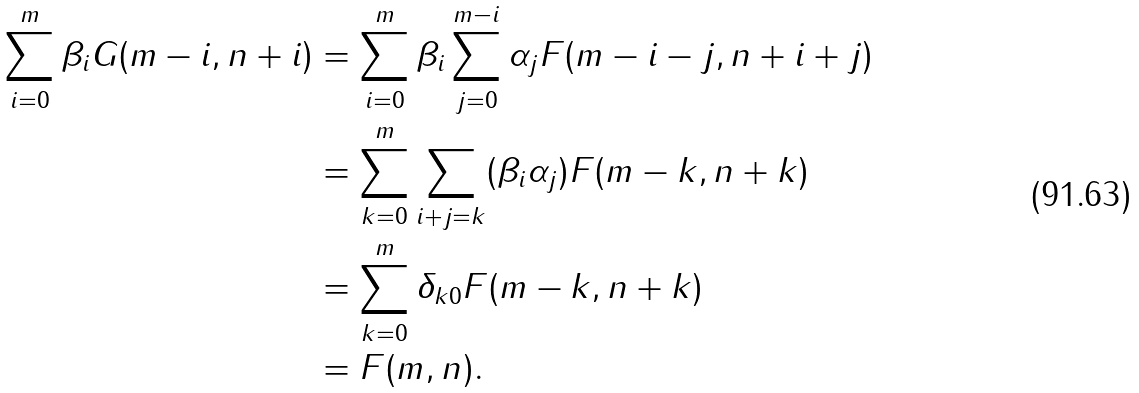<formula> <loc_0><loc_0><loc_500><loc_500>\sum _ { i = 0 } ^ { m } \beta _ { i } G ( m - i , n + i ) & = \sum _ { i = 0 } ^ { m } \beta _ { i } \sum _ { j = 0 } ^ { m - i } \alpha _ { j } F ( m - i - j , n + i + j ) \\ & = \sum _ { k = 0 } ^ { m } \sum _ { i + j = k } ( \beta _ { i } \alpha _ { j } ) F ( m - k , n + k ) \\ & = \sum _ { k = 0 } ^ { m } \delta _ { k 0 } F ( m - k , n + k ) \\ & = F ( m , n ) .</formula> 